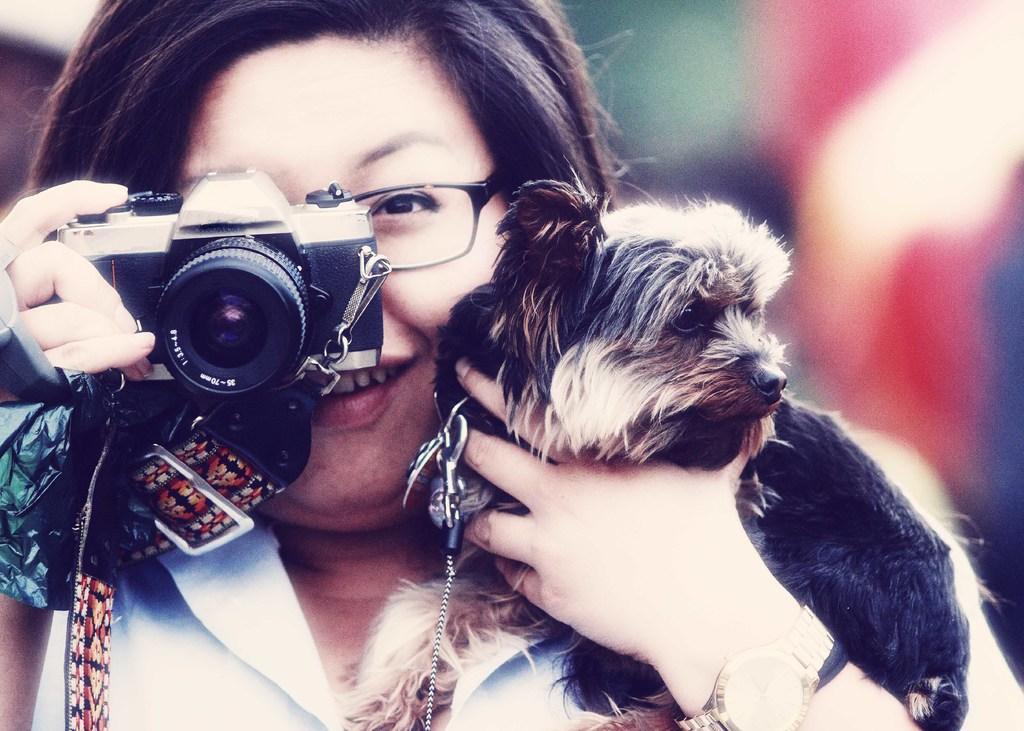How would you summarize this image in a sentence or two? In this picture we can see a women holding a dog with her hand and camera with other hand. She has spectacles and she is smiling. 